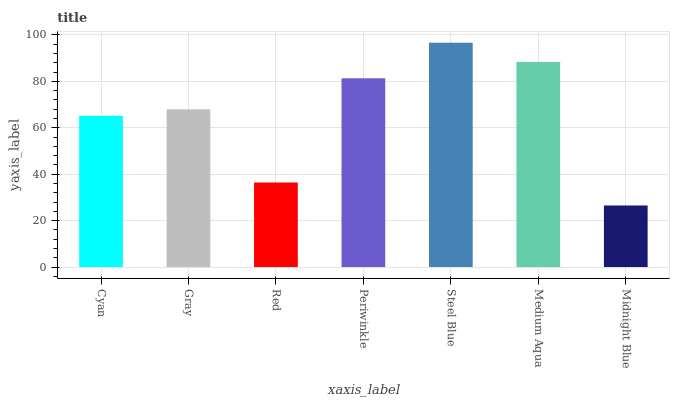Is Midnight Blue the minimum?
Answer yes or no. Yes. Is Steel Blue the maximum?
Answer yes or no. Yes. Is Gray the minimum?
Answer yes or no. No. Is Gray the maximum?
Answer yes or no. No. Is Gray greater than Cyan?
Answer yes or no. Yes. Is Cyan less than Gray?
Answer yes or no. Yes. Is Cyan greater than Gray?
Answer yes or no. No. Is Gray less than Cyan?
Answer yes or no. No. Is Gray the high median?
Answer yes or no. Yes. Is Gray the low median?
Answer yes or no. Yes. Is Medium Aqua the high median?
Answer yes or no. No. Is Cyan the low median?
Answer yes or no. No. 